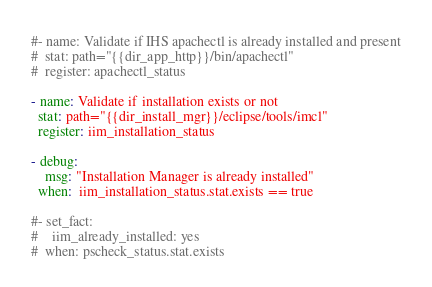<code> <loc_0><loc_0><loc_500><loc_500><_YAML_>#- name: Validate if IHS apachectl is already installed and present
#  stat: path="{{dir_app_http}}/bin/apachectl"
#  register: apachectl_status

- name: Validate if installation exists or not
  stat: path="{{dir_install_mgr}}/eclipse/tools/imcl"
  register: iim_installation_status

- debug:
    msg: "Installation Manager is already installed"
  when:  iim_installation_status.stat.exists == true

#- set_fact:
#    iim_already_installed: yes
#  when: pscheck_status.stat.exists
</code> 